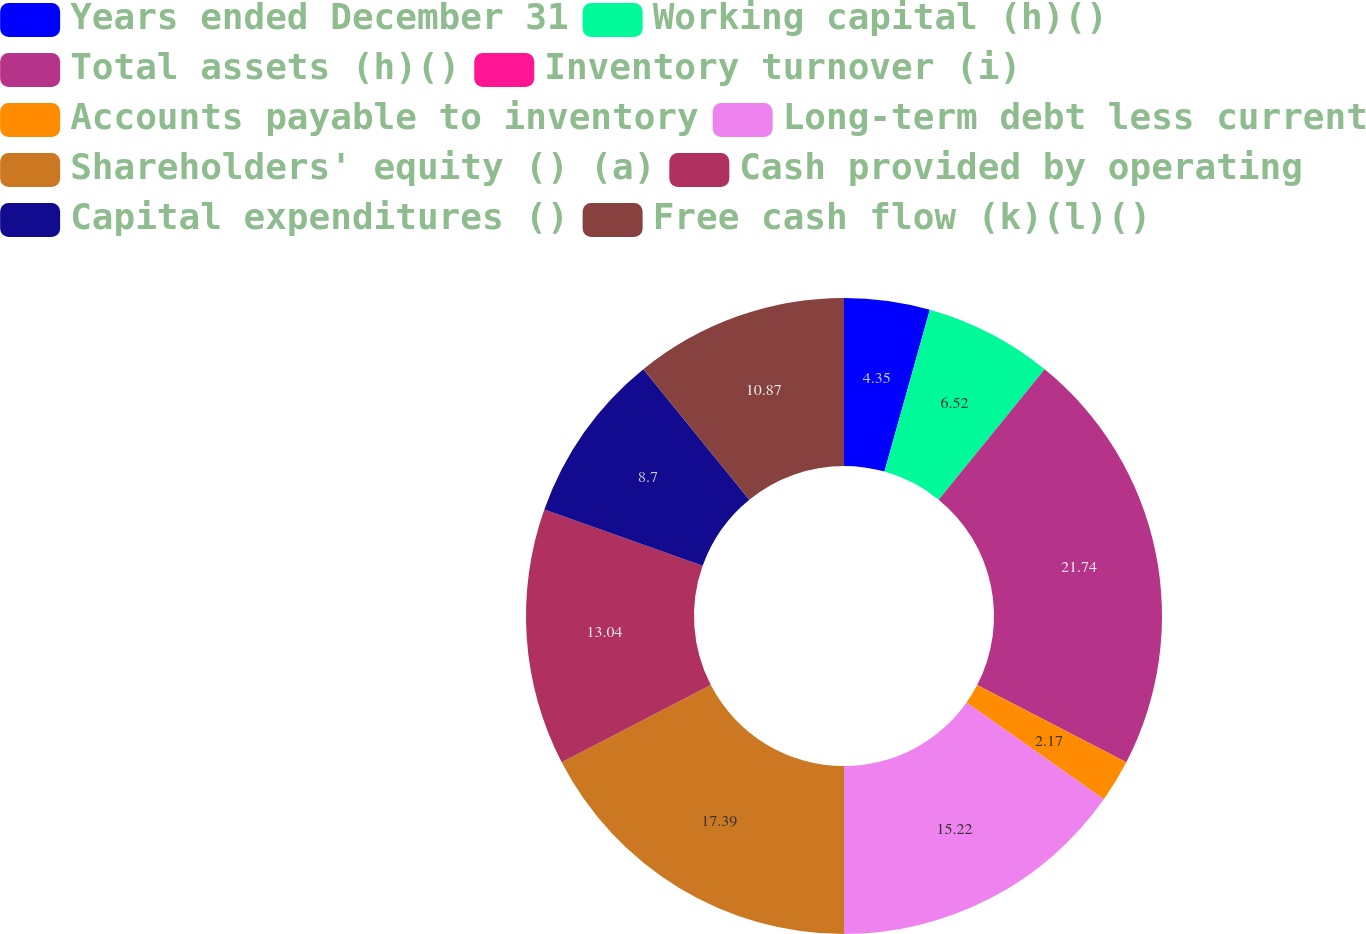Convert chart to OTSL. <chart><loc_0><loc_0><loc_500><loc_500><pie_chart><fcel>Years ended December 31<fcel>Working capital (h)()<fcel>Total assets (h)()<fcel>Inventory turnover (i)<fcel>Accounts payable to inventory<fcel>Long-term debt less current<fcel>Shareholders' equity () (a)<fcel>Cash provided by operating<fcel>Capital expenditures ()<fcel>Free cash flow (k)(l)()<nl><fcel>4.35%<fcel>6.52%<fcel>21.74%<fcel>0.0%<fcel>2.17%<fcel>15.22%<fcel>17.39%<fcel>13.04%<fcel>8.7%<fcel>10.87%<nl></chart> 